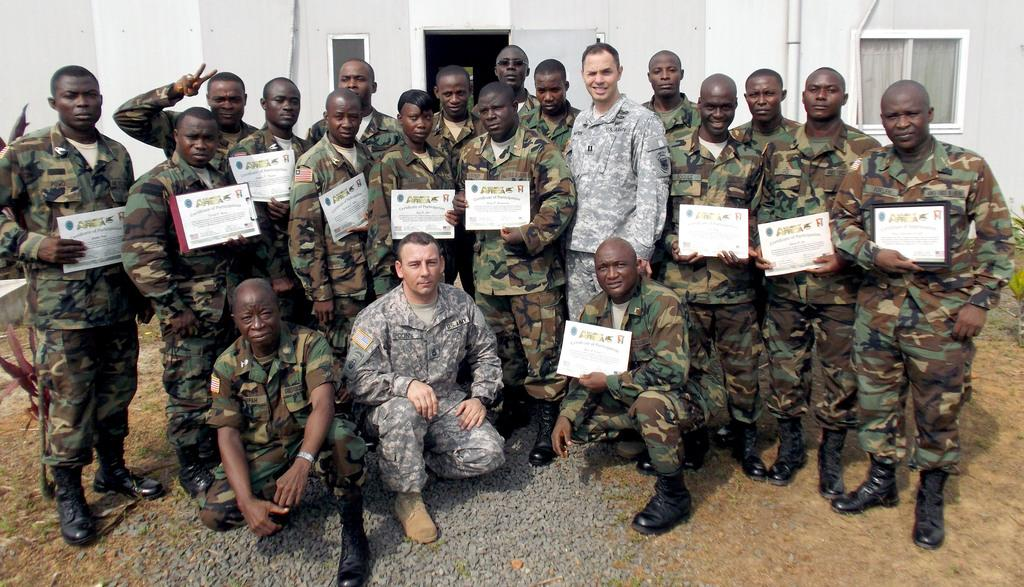What is happening in the image involving the group of people? The people in the image are holding certificates. What else can be seen in the image besides the group of people? There are plants and a building in the background of the image. What is the wealth of the plants in the image? The wealth of the plants cannot be determined from the image, as plants do not have wealth. 